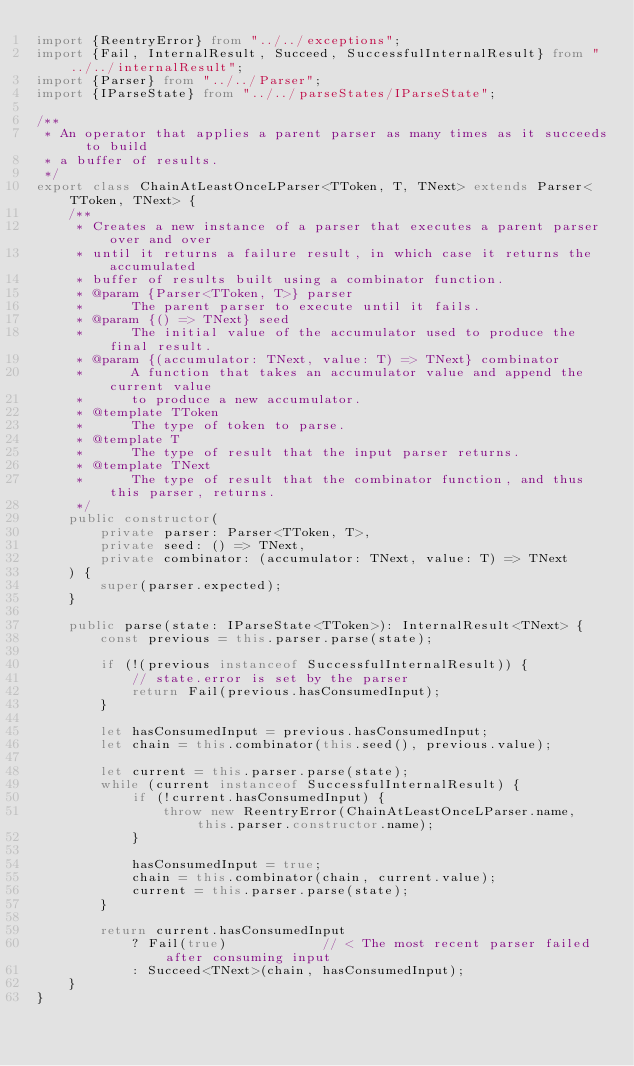Convert code to text. <code><loc_0><loc_0><loc_500><loc_500><_TypeScript_>import {ReentryError} from "../../exceptions";
import {Fail, InternalResult, Succeed, SuccessfulInternalResult} from "../../internalResult";
import {Parser} from "../../Parser";
import {IParseState} from "../../parseStates/IParseState";

/**
 * An operator that applies a parent parser as many times as it succeeds to build
 * a buffer of results.
 */
export class ChainAtLeastOnceLParser<TToken, T, TNext> extends Parser<TToken, TNext> {
    /**
     * Creates a new instance of a parser that executes a parent parser over and over
     * until it returns a failure result, in which case it returns the accumulated
     * buffer of results built using a combinator function.
     * @param {Parser<TToken, T>} parser
     *      The parent parser to execute until it fails.
     * @param {() => TNext} seed
     *      The initial value of the accumulator used to produce the final result.
     * @param {(accumulator: TNext, value: T) => TNext} combinator
     *      A function that takes an accumulator value and append the current value
     *      to produce a new accumulator.
     * @template TToken
     *      The type of token to parse.
     * @template T
     *      The type of result that the input parser returns.
     * @template TNext
     *      The type of result that the combinator function, and thus this parser, returns.
     */
    public constructor(
        private parser: Parser<TToken, T>,
        private seed: () => TNext,
        private combinator: (accumulator: TNext, value: T) => TNext
    ) {
        super(parser.expected);
    }

    public parse(state: IParseState<TToken>): InternalResult<TNext> {
        const previous = this.parser.parse(state);

        if (!(previous instanceof SuccessfulInternalResult)) {
            // state.error is set by the parser
            return Fail(previous.hasConsumedInput);
        }

        let hasConsumedInput = previous.hasConsumedInput;
        let chain = this.combinator(this.seed(), previous.value);

        let current = this.parser.parse(state);
        while (current instanceof SuccessfulInternalResult) {
            if (!current.hasConsumedInput) {
                throw new ReentryError(ChainAtLeastOnceLParser.name, this.parser.constructor.name);
            }

            hasConsumedInput = true;
            chain = this.combinator(chain, current.value);
            current = this.parser.parse(state);
        }

        return current.hasConsumedInput
            ? Fail(true)            // < The most recent parser failed after consuming input
            : Succeed<TNext>(chain, hasConsumedInput);
    }
}
</code> 